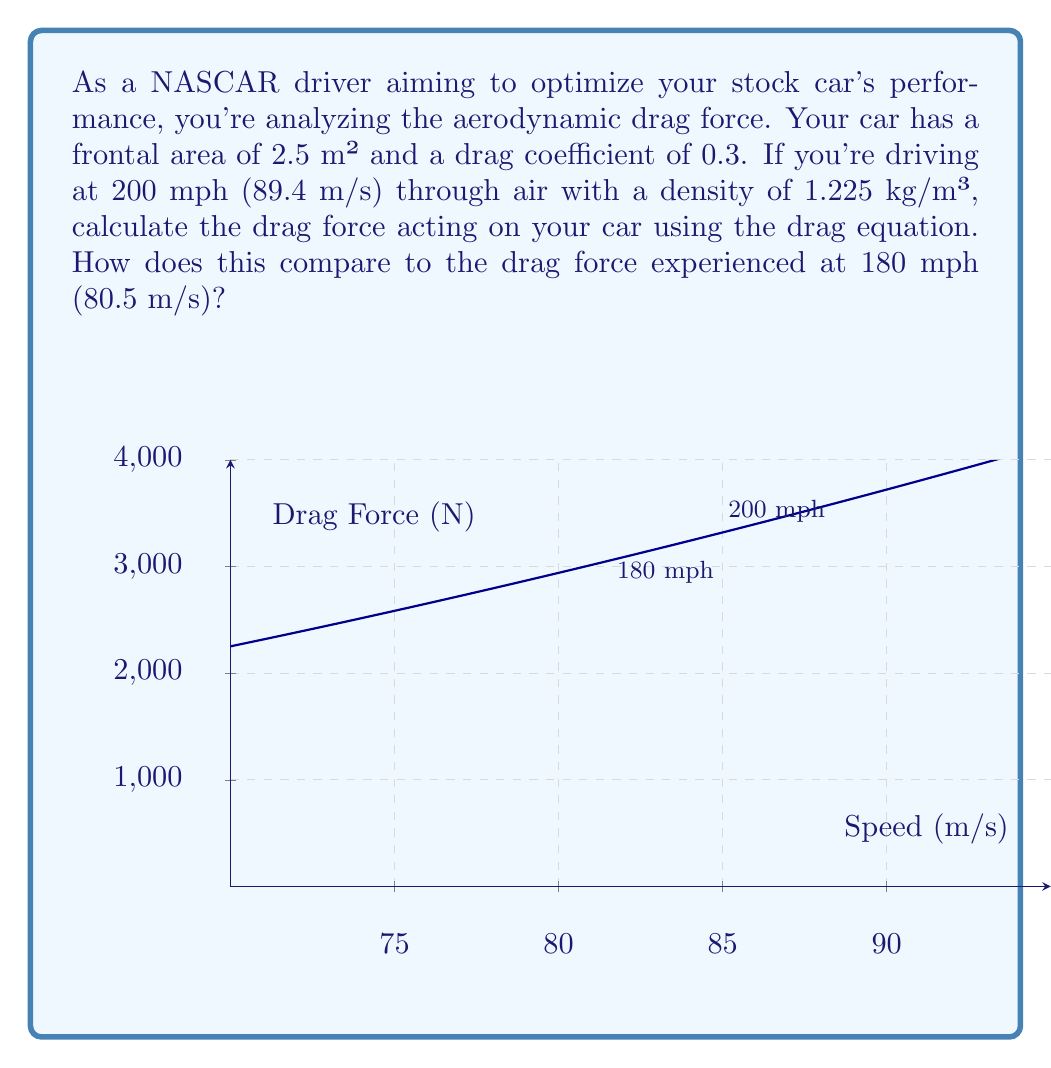Solve this math problem. Let's approach this step-by-step using the drag equation:

1) The drag equation is:

   $$F_D = \frac{1}{2} \rho v^2 C_D A$$

   Where:
   $F_D$ = drag force
   $\rho$ = air density
   $v$ = velocity
   $C_D$ = drag coefficient
   $A$ = frontal area

2) We're given:
   $\rho = 1.225$ kg/m³
   $C_D = 0.3$
   $A = 2.5$ m²

3) For 200 mph (89.4 m/s):
   $$F_D = \frac{1}{2} (1.225)(89.4^2)(0.3)(2.5)$$
   $$F_D = 3,676.5 \text{ N}$$

4) For 180 mph (80.5 m/s):
   $$F_D = \frac{1}{2} (1.225)(80.5^2)(0.3)(2.5)$$
   $$F_D = 2,981.7 \text{ N}$$

5) Comparing the two:
   Difference = 3,676.5 - 2,981.7 = 694.8 N
   Percentage increase = (694.8 / 2,981.7) * 100 ≈ 23.3%

The drag force at 200 mph is about 23.3% higher than at 180 mph, demonstrating the significant increase in aerodynamic resistance at higher speeds.
Answer: At 200 mph: 3,676.5 N; At 180 mph: 2,981.7 N; 23.3% increase 